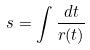<formula> <loc_0><loc_0><loc_500><loc_500>s = \int \frac { d t } { r ( t ) }</formula> 